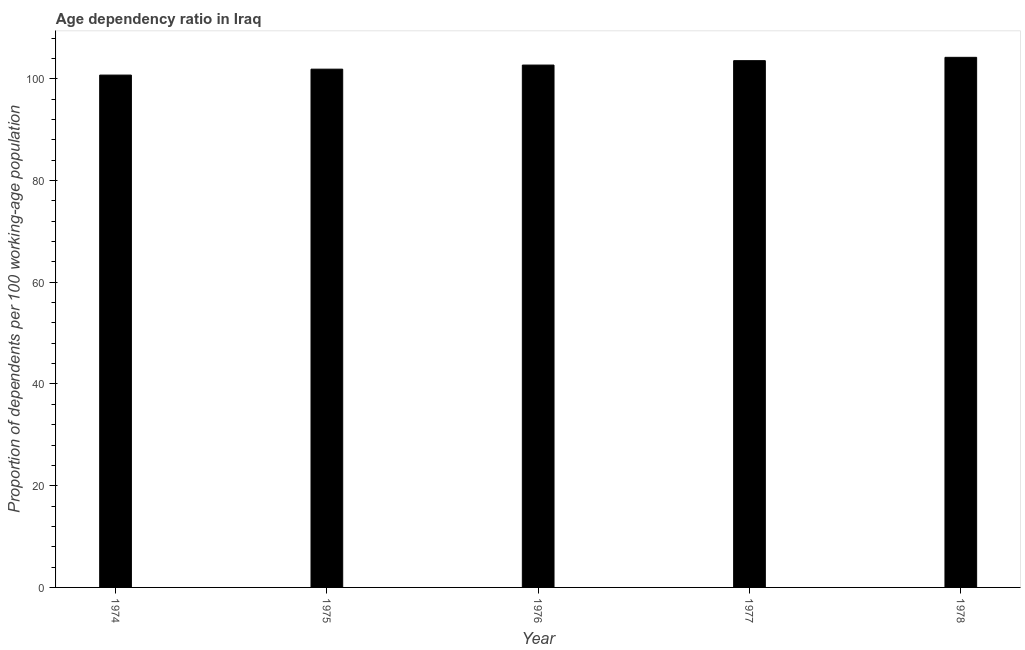Does the graph contain any zero values?
Keep it short and to the point. No. Does the graph contain grids?
Keep it short and to the point. No. What is the title of the graph?
Offer a very short reply. Age dependency ratio in Iraq. What is the label or title of the X-axis?
Provide a short and direct response. Year. What is the label or title of the Y-axis?
Your answer should be very brief. Proportion of dependents per 100 working-age population. What is the age dependency ratio in 1977?
Make the answer very short. 103.56. Across all years, what is the maximum age dependency ratio?
Give a very brief answer. 104.22. Across all years, what is the minimum age dependency ratio?
Offer a terse response. 100.72. In which year was the age dependency ratio maximum?
Give a very brief answer. 1978. In which year was the age dependency ratio minimum?
Give a very brief answer. 1974. What is the sum of the age dependency ratio?
Your response must be concise. 513.08. What is the difference between the age dependency ratio in 1974 and 1977?
Your response must be concise. -2.83. What is the average age dependency ratio per year?
Your response must be concise. 102.62. What is the median age dependency ratio?
Offer a terse response. 102.69. Is the difference between the age dependency ratio in 1976 and 1977 greater than the difference between any two years?
Keep it short and to the point. No. What is the difference between the highest and the second highest age dependency ratio?
Offer a very short reply. 0.66. Is the sum of the age dependency ratio in 1974 and 1977 greater than the maximum age dependency ratio across all years?
Keep it short and to the point. Yes. What is the difference between the highest and the lowest age dependency ratio?
Provide a succinct answer. 3.49. Are all the bars in the graph horizontal?
Provide a short and direct response. No. What is the Proportion of dependents per 100 working-age population of 1974?
Keep it short and to the point. 100.72. What is the Proportion of dependents per 100 working-age population in 1975?
Your answer should be very brief. 101.89. What is the Proportion of dependents per 100 working-age population of 1976?
Your response must be concise. 102.69. What is the Proportion of dependents per 100 working-age population in 1977?
Your answer should be compact. 103.56. What is the Proportion of dependents per 100 working-age population of 1978?
Provide a short and direct response. 104.22. What is the difference between the Proportion of dependents per 100 working-age population in 1974 and 1975?
Your response must be concise. -1.17. What is the difference between the Proportion of dependents per 100 working-age population in 1974 and 1976?
Your answer should be very brief. -1.97. What is the difference between the Proportion of dependents per 100 working-age population in 1974 and 1977?
Offer a terse response. -2.84. What is the difference between the Proportion of dependents per 100 working-age population in 1974 and 1978?
Make the answer very short. -3.49. What is the difference between the Proportion of dependents per 100 working-age population in 1975 and 1976?
Provide a succinct answer. -0.8. What is the difference between the Proportion of dependents per 100 working-age population in 1975 and 1977?
Offer a very short reply. -1.67. What is the difference between the Proportion of dependents per 100 working-age population in 1975 and 1978?
Ensure brevity in your answer.  -2.33. What is the difference between the Proportion of dependents per 100 working-age population in 1976 and 1977?
Offer a very short reply. -0.87. What is the difference between the Proportion of dependents per 100 working-age population in 1976 and 1978?
Offer a very short reply. -1.52. What is the difference between the Proportion of dependents per 100 working-age population in 1977 and 1978?
Make the answer very short. -0.66. What is the ratio of the Proportion of dependents per 100 working-age population in 1974 to that in 1976?
Make the answer very short. 0.98. What is the ratio of the Proportion of dependents per 100 working-age population in 1975 to that in 1977?
Provide a succinct answer. 0.98. What is the ratio of the Proportion of dependents per 100 working-age population in 1975 to that in 1978?
Ensure brevity in your answer.  0.98. What is the ratio of the Proportion of dependents per 100 working-age population in 1976 to that in 1977?
Offer a very short reply. 0.99. 